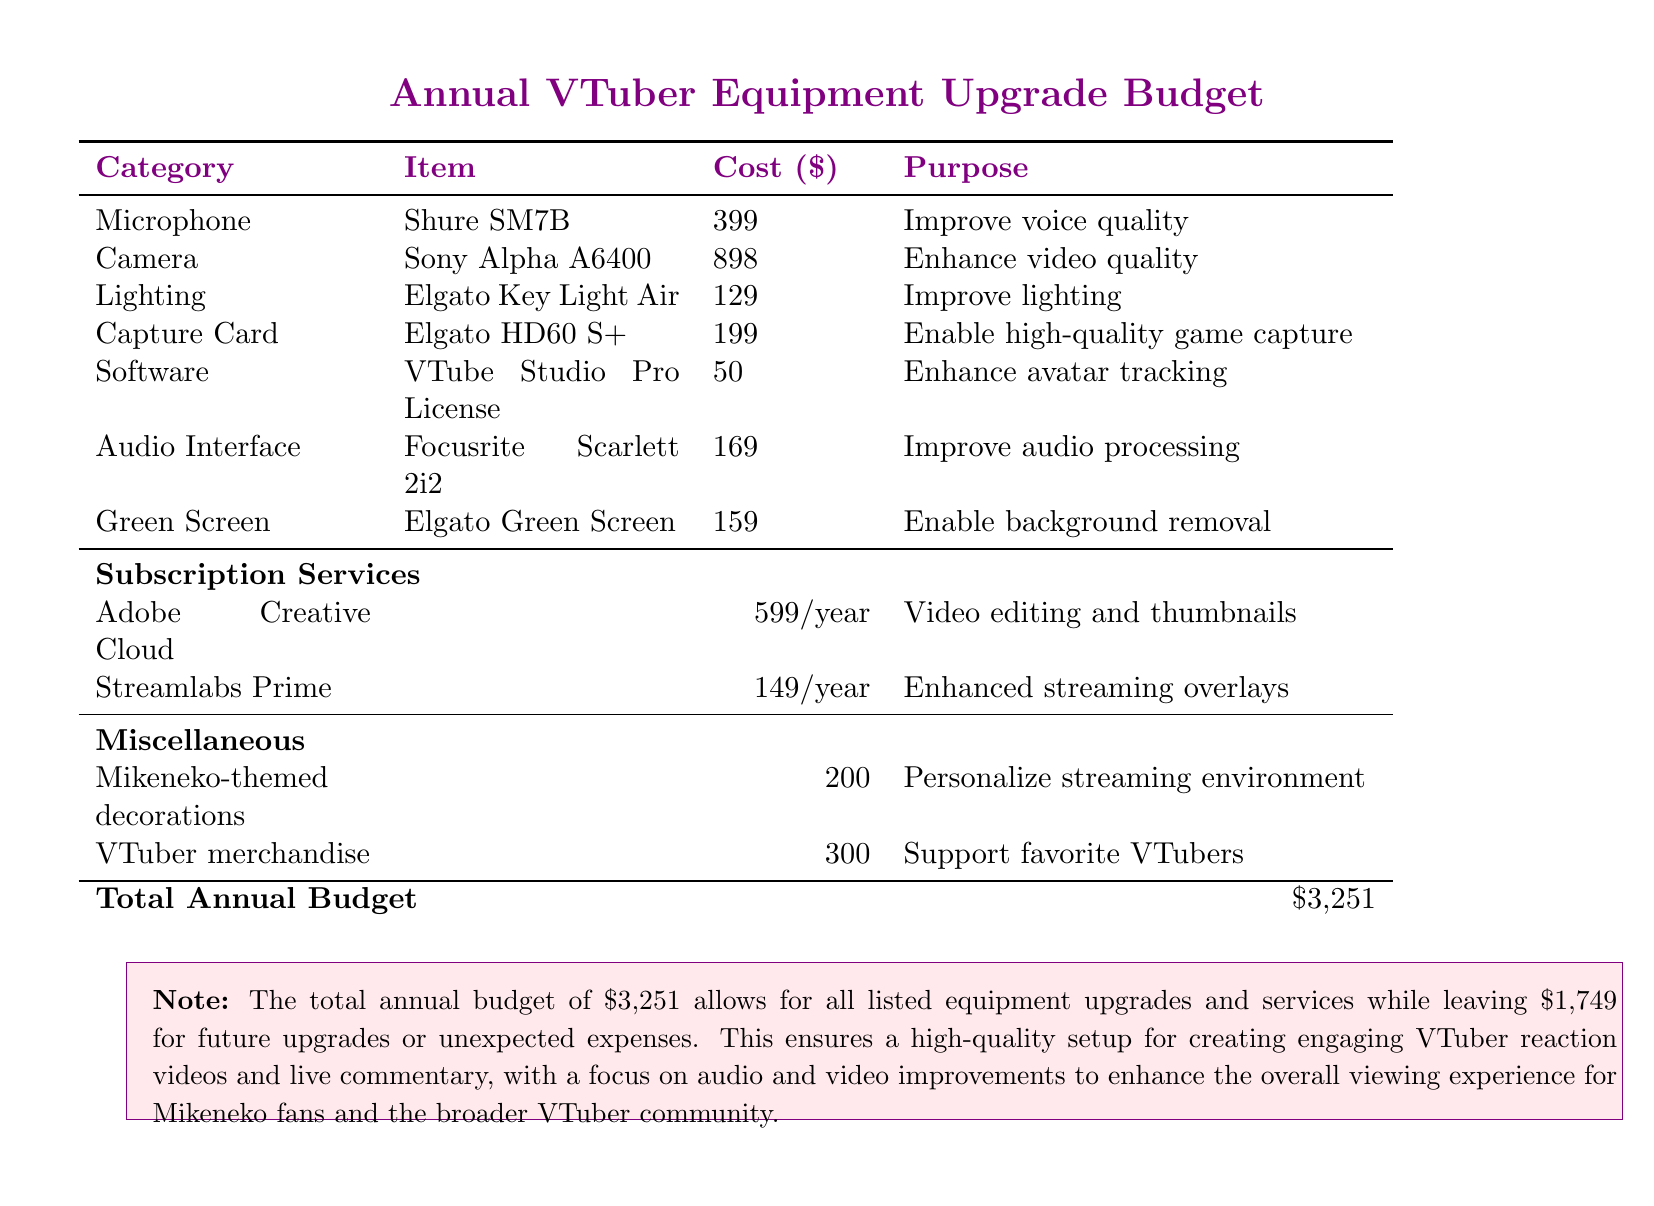What is the total cost of the microphone? The microphone listed is the Shure SM7B, which costs $399.
Answer: $399 How much does the Sony Alpha A6400 camera cost? The camera is priced at $898 in the document.
Answer: $898 What is the annual cost of the Adobe Creative Cloud subscription? The document states that Adobe Creative Cloud costs $599 per year.
Answer: $599/year What purpose does the Elgato Green Screen serve? The Elgato Green Screen is intended for background removal.
Answer: Background removal What is the total annual budget listed? The document specifies the total annual budget as $3,251.
Answer: $3,251 How much is allocated for VTuber merchandise? The budget for VTuber merchandise is $300 according to the document.
Answer: $300 What equipment is mentioned for enhancing avatar tracking? The VTube Studio Pro License is listed for enhancing avatar tracking.
Answer: VTube Studio Pro License What is the purpose of the Focusrite Scarlett 2i2? It is used to improve audio processing as per the document.
Answer: Improve audio processing How much is remaining for future upgrades or unexpected expenses? The document notes that $1,749 is left for future upgrades or unexpected expenses.
Answer: $1,749 